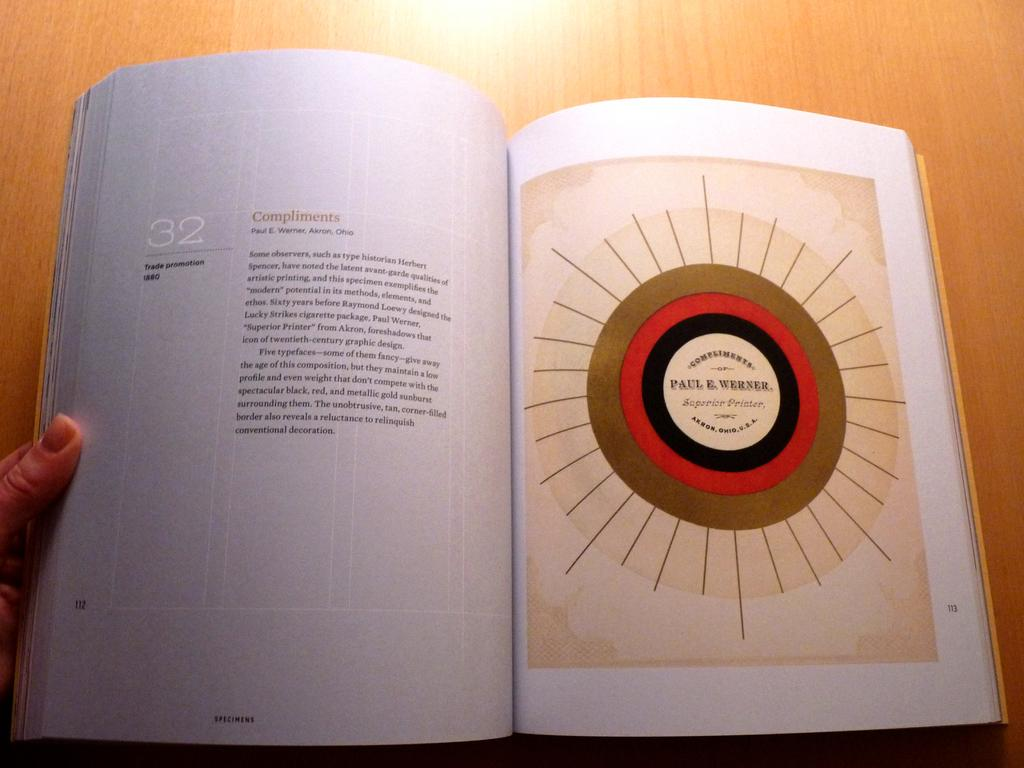<image>
Relay a brief, clear account of the picture shown. Chapter 32 of the book starts on page 112. 